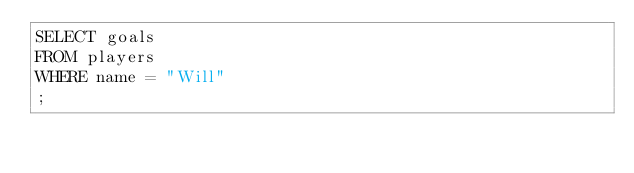<code> <loc_0><loc_0><loc_500><loc_500><_SQL_>SELECT goals
FROM players
WHERE name = "Will"
;</code> 